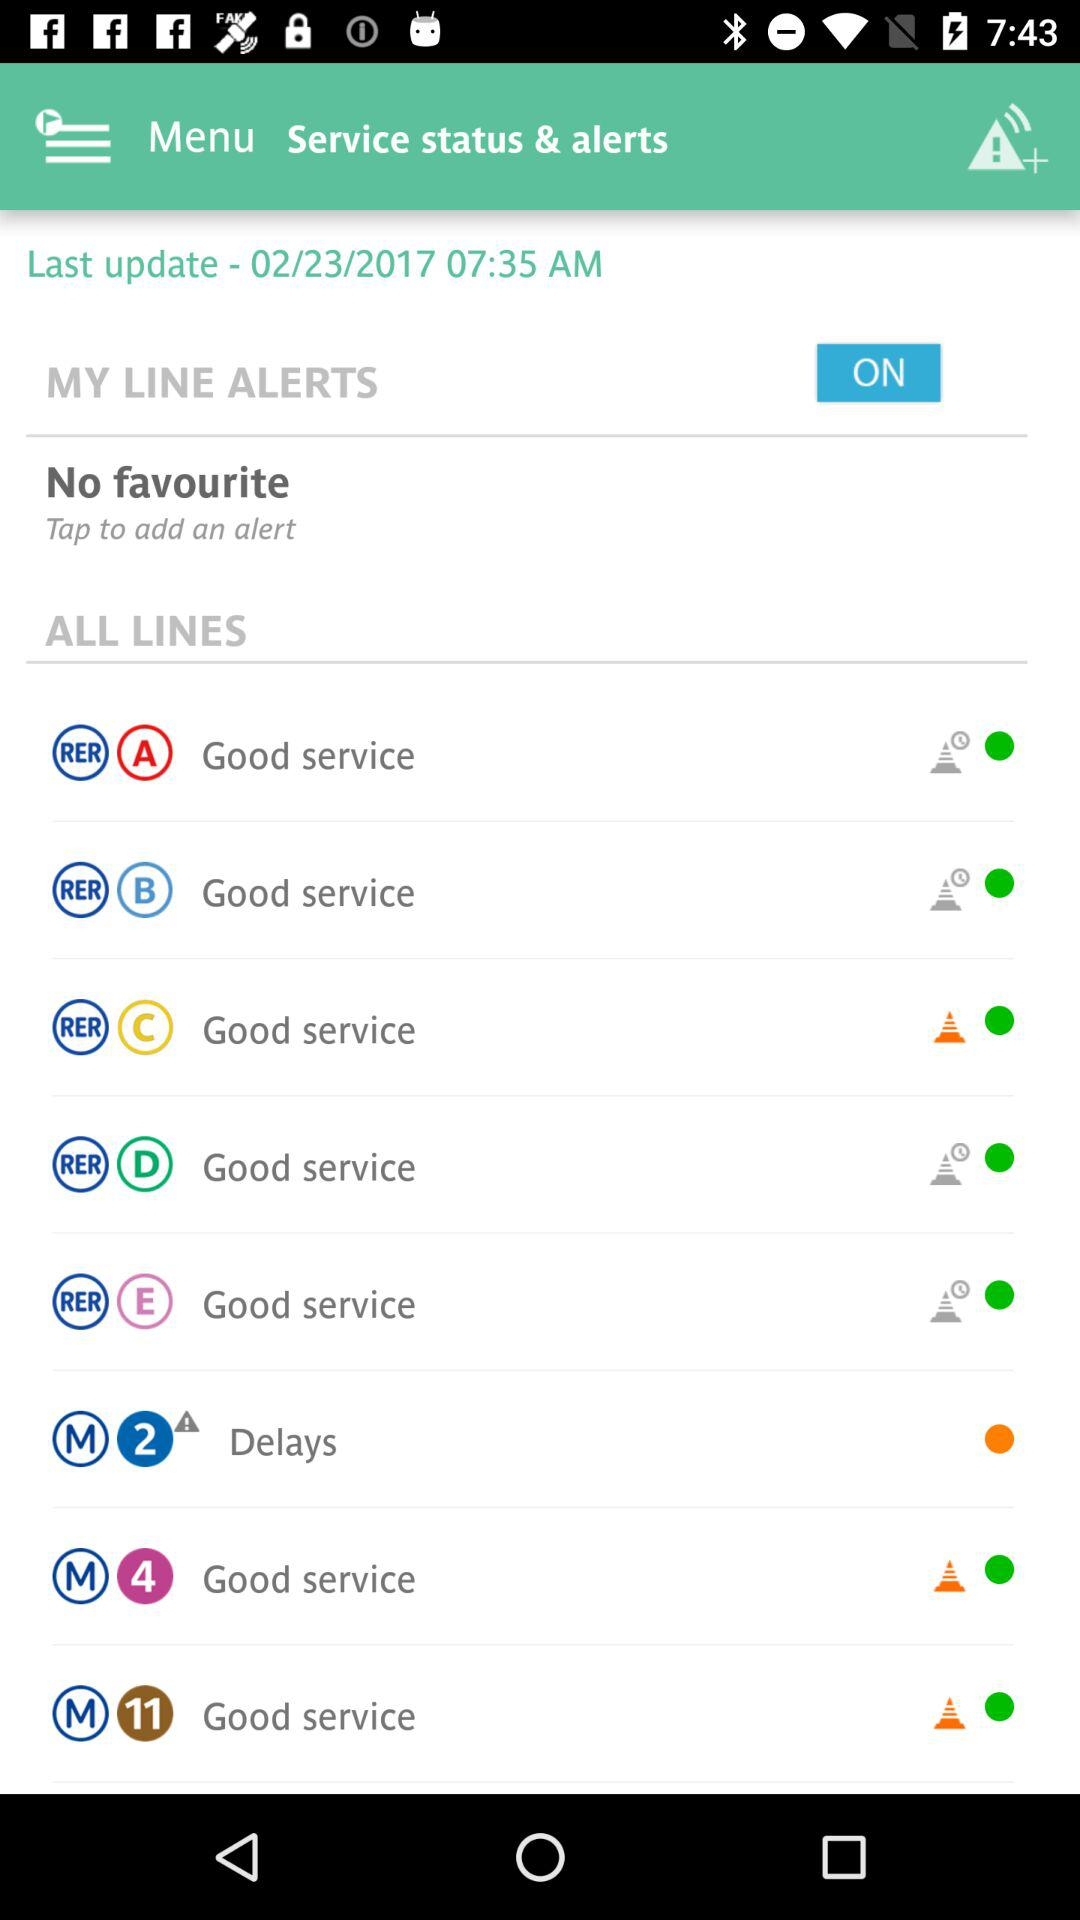Is "ALL LINES" checked or unchecked?
When the provided information is insufficient, respond with <no answer>. <no answer> 